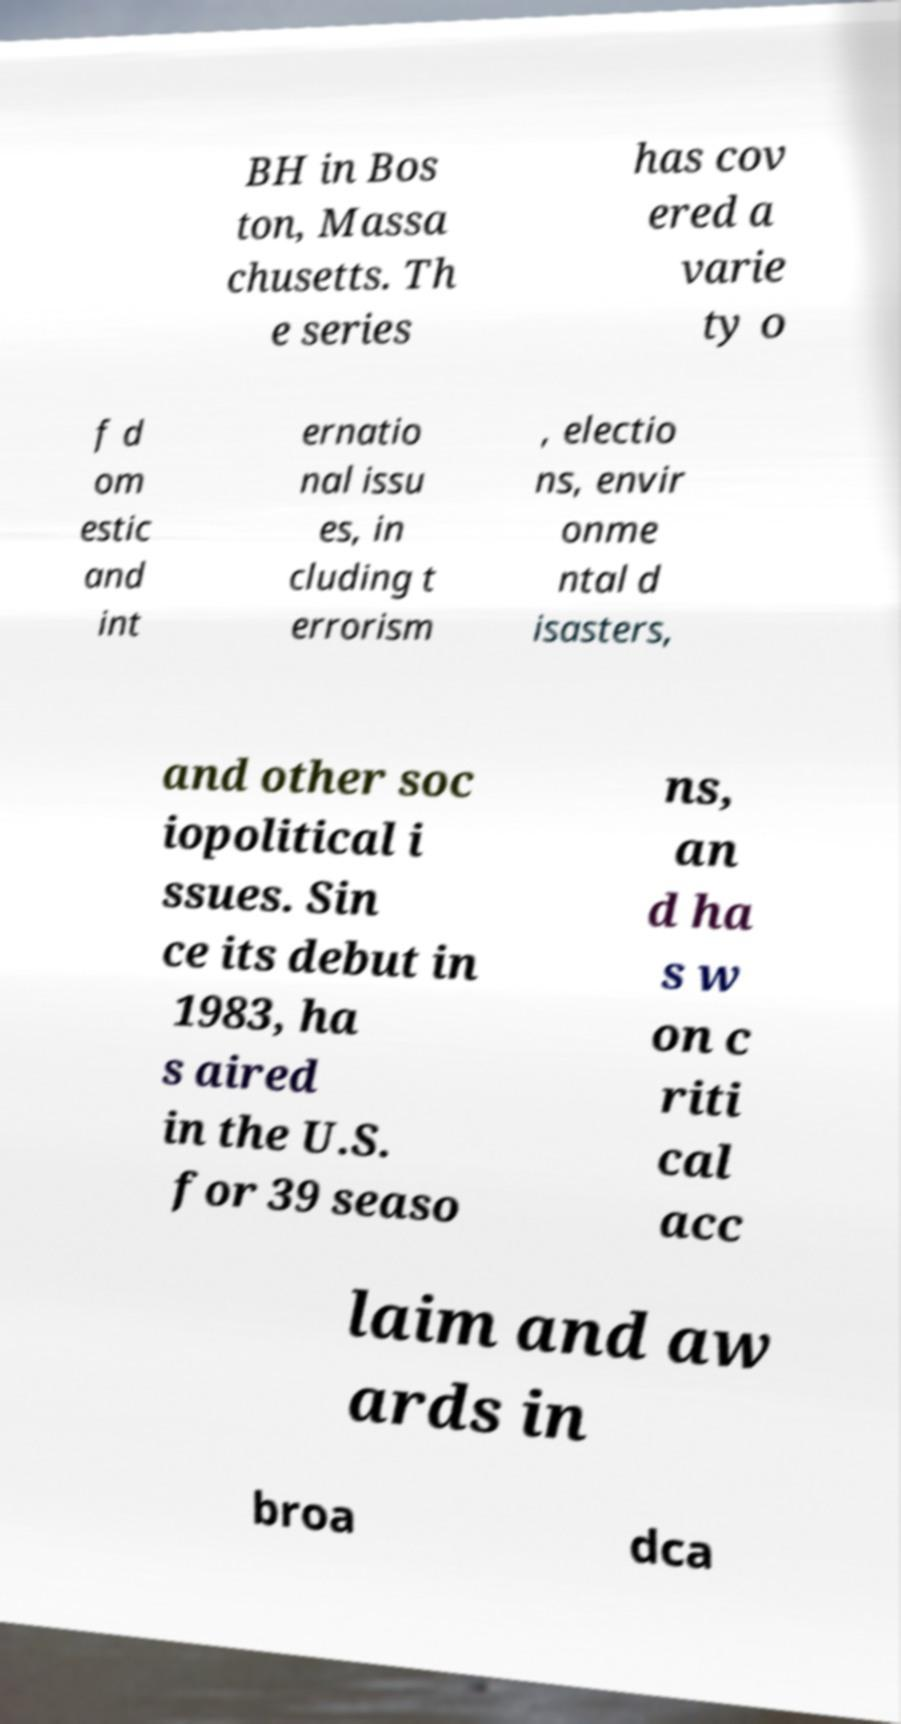What messages or text are displayed in this image? I need them in a readable, typed format. BH in Bos ton, Massa chusetts. Th e series has cov ered a varie ty o f d om estic and int ernatio nal issu es, in cluding t errorism , electio ns, envir onme ntal d isasters, and other soc iopolitical i ssues. Sin ce its debut in 1983, ha s aired in the U.S. for 39 seaso ns, an d ha s w on c riti cal acc laim and aw ards in broa dca 